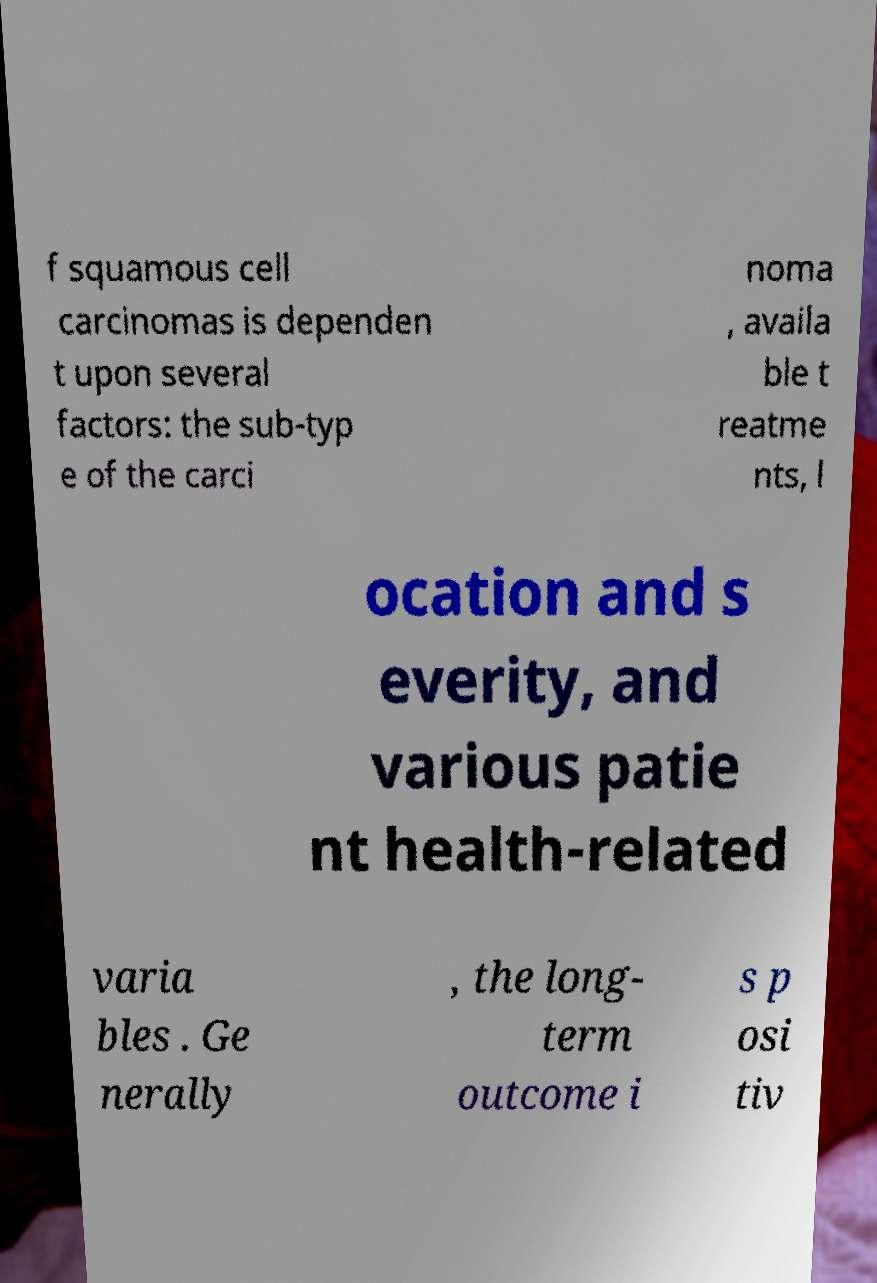Could you extract and type out the text from this image? f squamous cell carcinomas is dependen t upon several factors: the sub-typ e of the carci noma , availa ble t reatme nts, l ocation and s everity, and various patie nt health-related varia bles . Ge nerally , the long- term outcome i s p osi tiv 